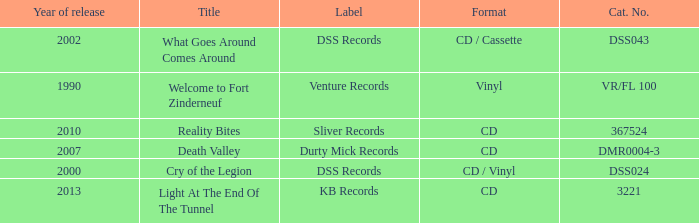What is the total year of release of the title what goes around comes around? 1.0. 